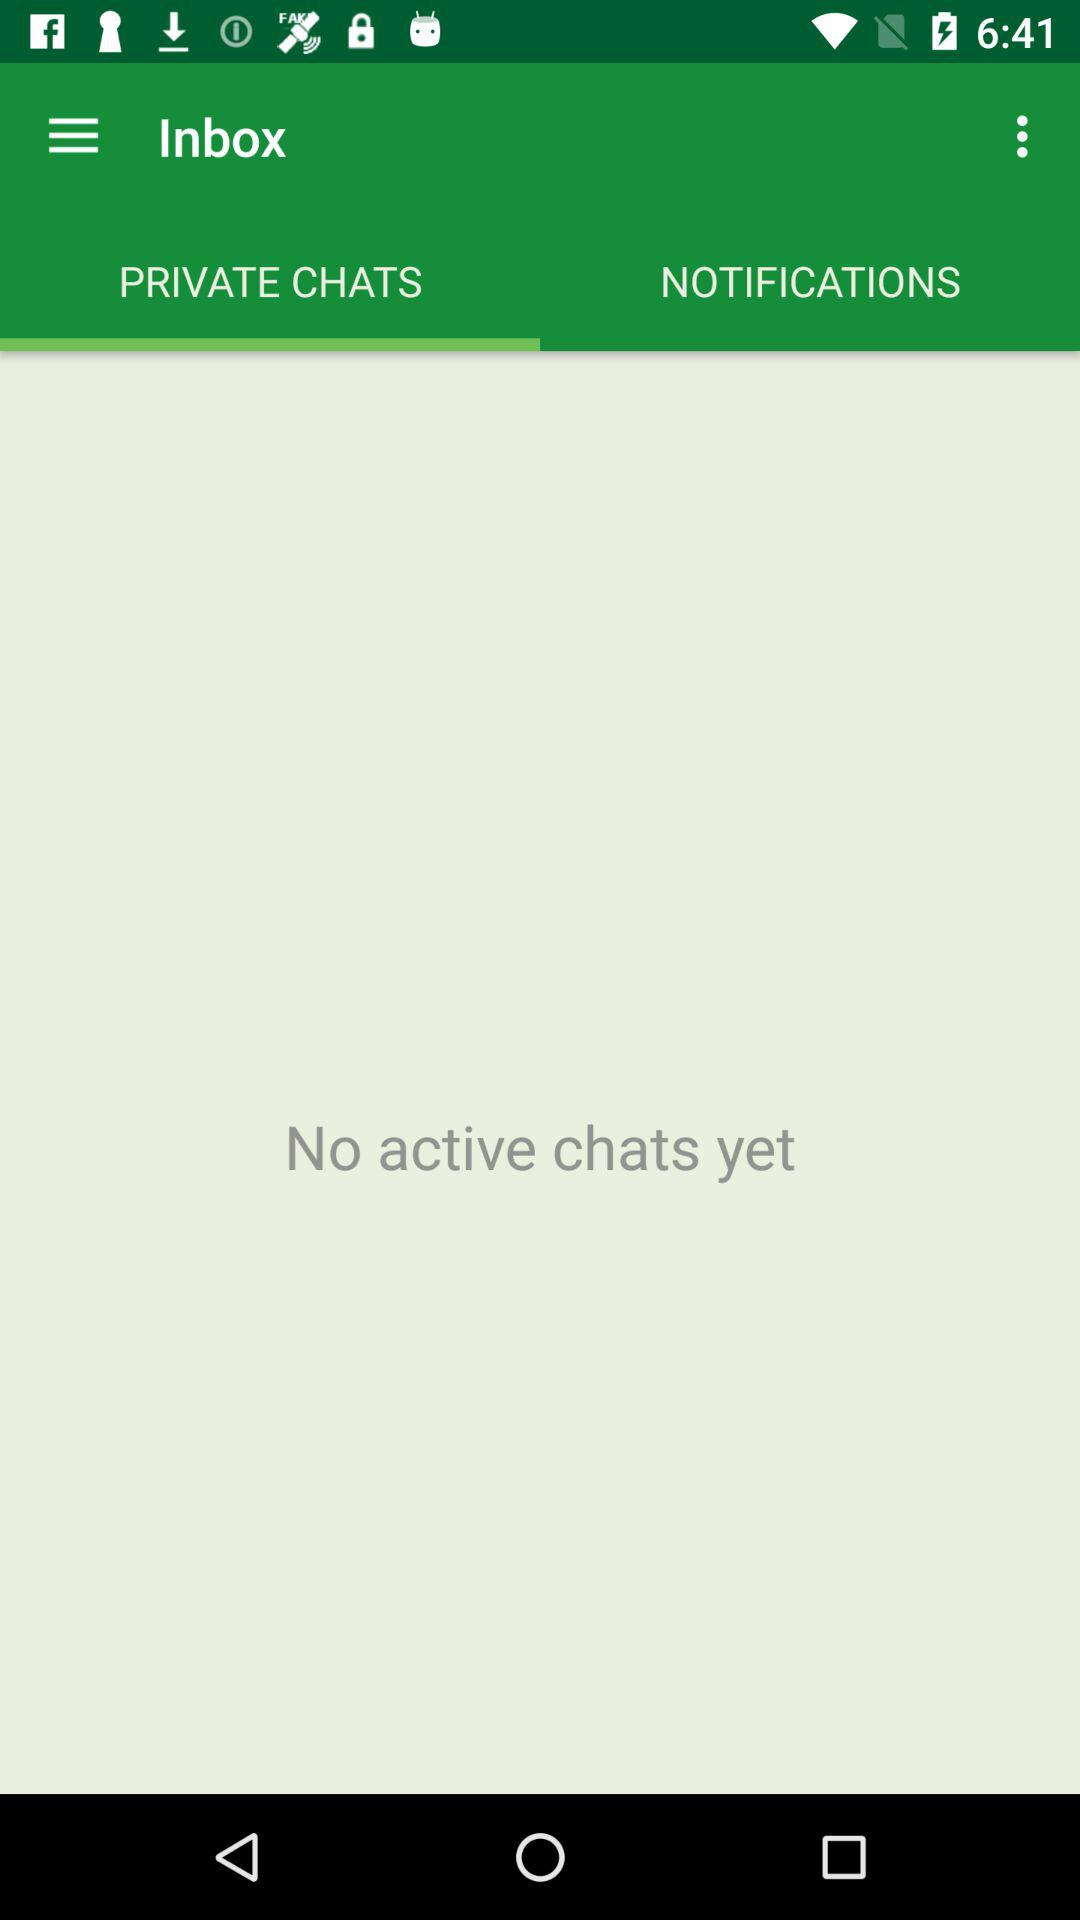How many active chats do I have?
Answer the question using a single word or phrase. 0 